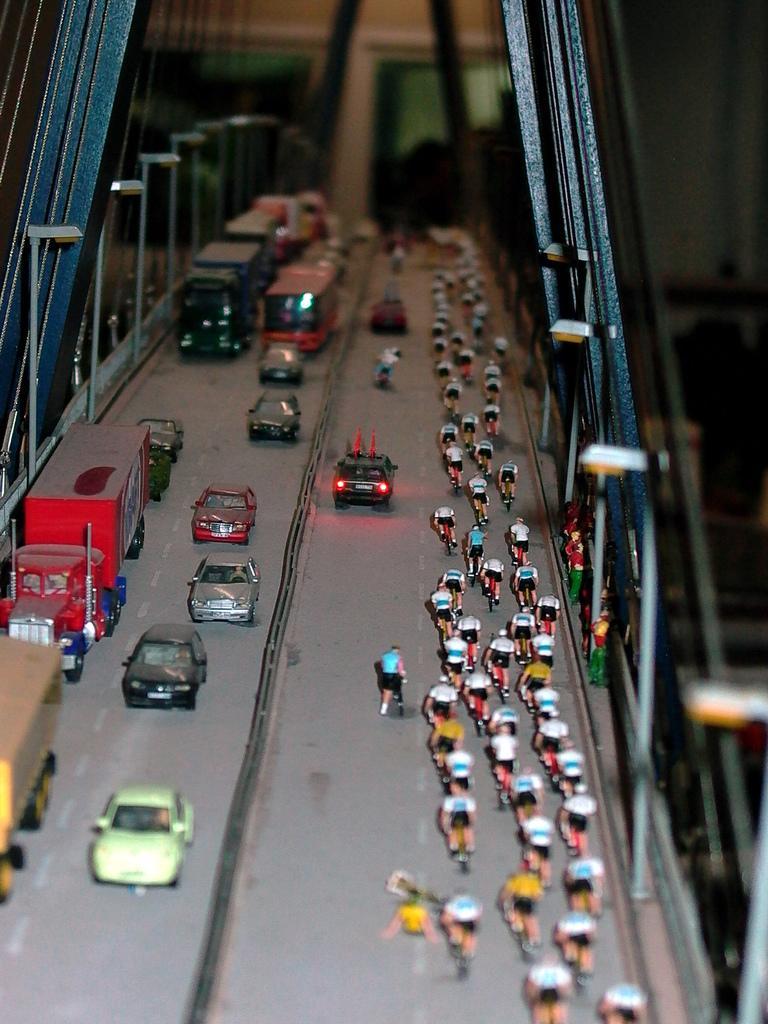Please provide a concise description of this image. Here we can see a miniature, in this miniature we can see a bridge in the front, there are some vehicles traveling on the bridge, on the right side we can see some people riding bicycles, there is a blurry background, we can see some wires on the left side. 